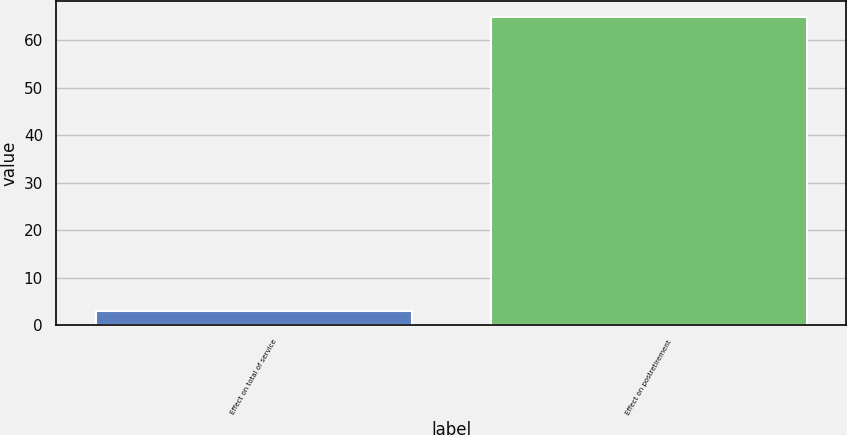Convert chart to OTSL. <chart><loc_0><loc_0><loc_500><loc_500><bar_chart><fcel>Effect on total of service<fcel>Effect on postretirement<nl><fcel>3<fcel>65<nl></chart> 